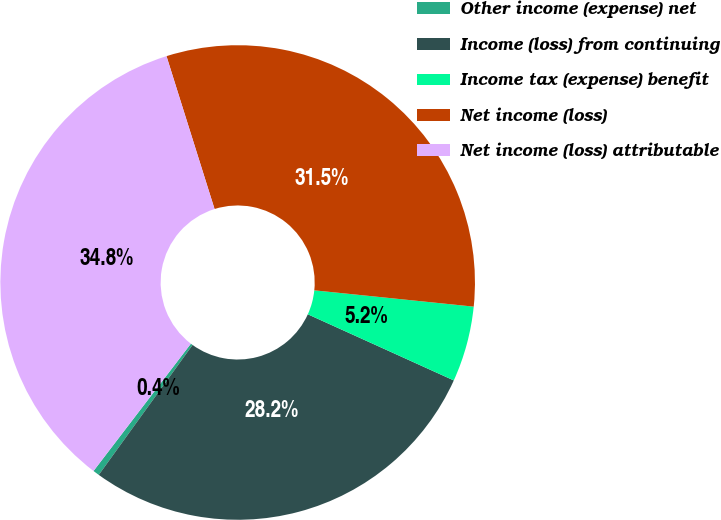Convert chart. <chart><loc_0><loc_0><loc_500><loc_500><pie_chart><fcel>Other income (expense) net<fcel>Income (loss) from continuing<fcel>Income tax (expense) benefit<fcel>Net income (loss)<fcel>Net income (loss) attributable<nl><fcel>0.44%<fcel>28.18%<fcel>5.15%<fcel>31.47%<fcel>34.76%<nl></chart> 